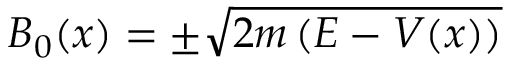Convert formula to latex. <formula><loc_0><loc_0><loc_500><loc_500>B _ { 0 } ( x ) = \pm { \sqrt { 2 m \left ( E - V ( x ) \right ) } }</formula> 